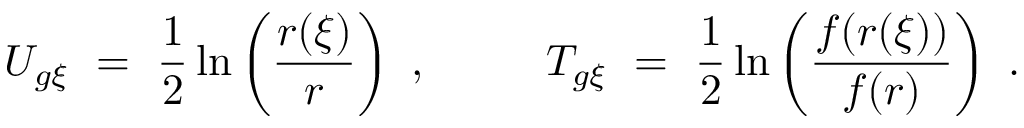Convert formula to latex. <formula><loc_0><loc_0><loc_500><loc_500>U _ { g \xi } \ = \ \frac { 1 } { 2 } \ln \left ( \frac { r ( \xi ) } { r } \right ) \ , \quad T _ { g \xi } \ = \ \frac { 1 } { 2 } \ln \left ( \frac { f ( r ( \xi ) ) } { f ( r ) } \right ) \ .</formula> 